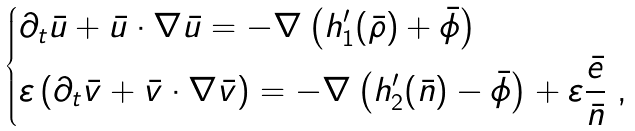Convert formula to latex. <formula><loc_0><loc_0><loc_500><loc_500>\begin{dcases} \partial _ { t } \bar { u } + \bar { u } \cdot \nabla \bar { u } = - \nabla \left ( h _ { 1 } ^ { \prime } ( \bar { \rho } ) + \bar { \phi } \right ) \\ \varepsilon \left ( \partial _ { t } \bar { v } + \bar { v } \cdot \nabla \bar { v } \right ) = - \nabla \left ( h _ { 2 } ^ { \prime } ( \bar { n } ) - \bar { \phi } \right ) + \varepsilon \frac { \bar { e } } { \bar { n } } \ , \end{dcases}</formula> 